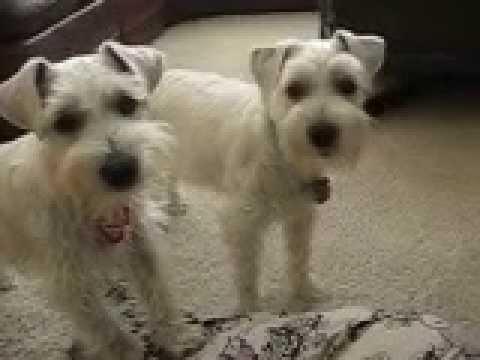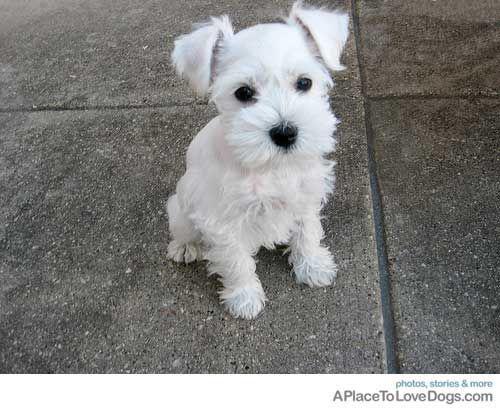The first image is the image on the left, the second image is the image on the right. For the images shown, is this caption "a single dog is sitting on a tile floor" true? Answer yes or no. Yes. The first image is the image on the left, the second image is the image on the right. Evaluate the accuracy of this statement regarding the images: "One puppy is sitting on tile flooring.". Is it true? Answer yes or no. Yes. 